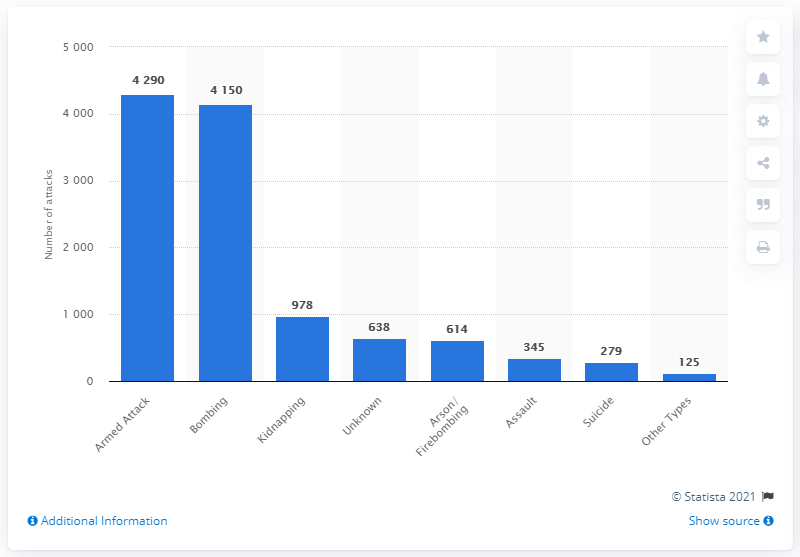Mention a couple of crucial points in this snapshot. In 2011, during a terrorist attack, 279 terrorists committed suicide. 